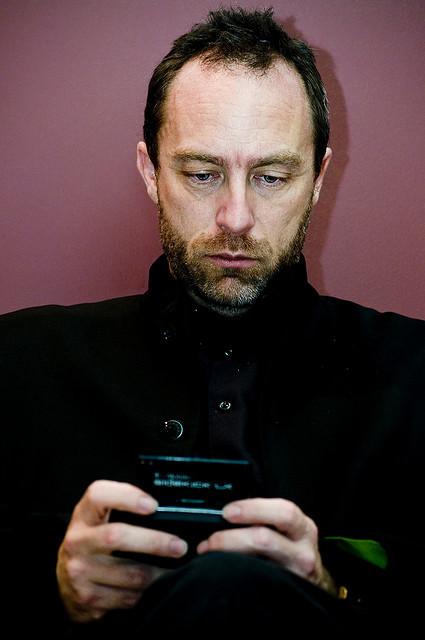What Is the man holding?
Quick response, please. Phone. Is the person happy?
Be succinct. No. What is this man doing?
Be succinct. Texting. 